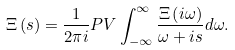Convert formula to latex. <formula><loc_0><loc_0><loc_500><loc_500>\Xi \left ( s \right ) = \frac { 1 } { 2 \pi i } P V \int _ { - \infty } ^ { \infty } \frac { \Xi \left ( i \omega \right ) } { \omega + i s } d \omega .</formula> 